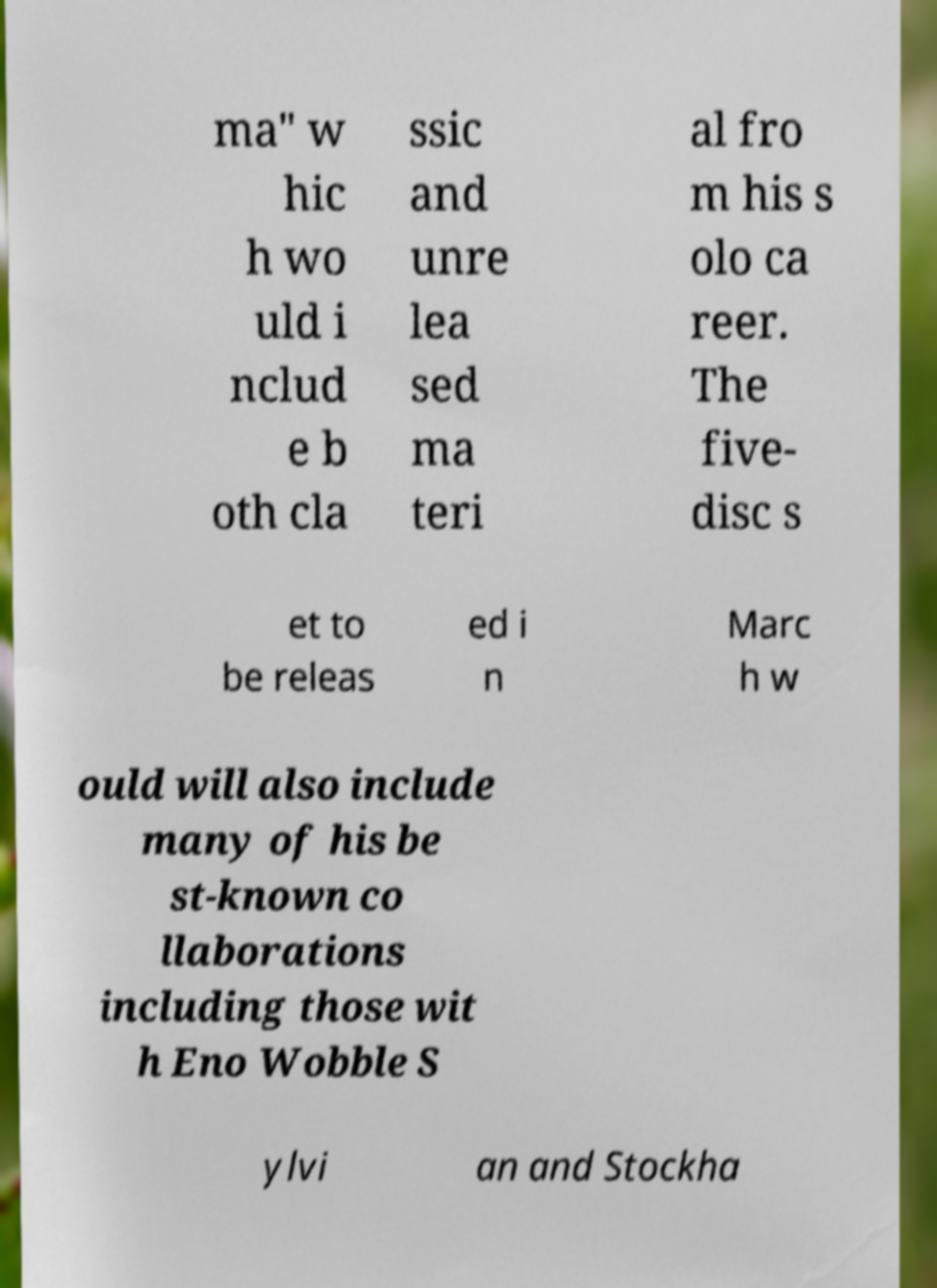Can you accurately transcribe the text from the provided image for me? ma" w hic h wo uld i nclud e b oth cla ssic and unre lea sed ma teri al fro m his s olo ca reer. The five- disc s et to be releas ed i n Marc h w ould will also include many of his be st-known co llaborations including those wit h Eno Wobble S ylvi an and Stockha 